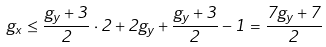<formula> <loc_0><loc_0><loc_500><loc_500>g _ { x } \leq \frac { g _ { y } + 3 } { 2 } \cdot 2 + 2 g _ { y } + \frac { g _ { y } + 3 } { 2 } - 1 = \frac { 7 g _ { y } + 7 } { 2 }</formula> 